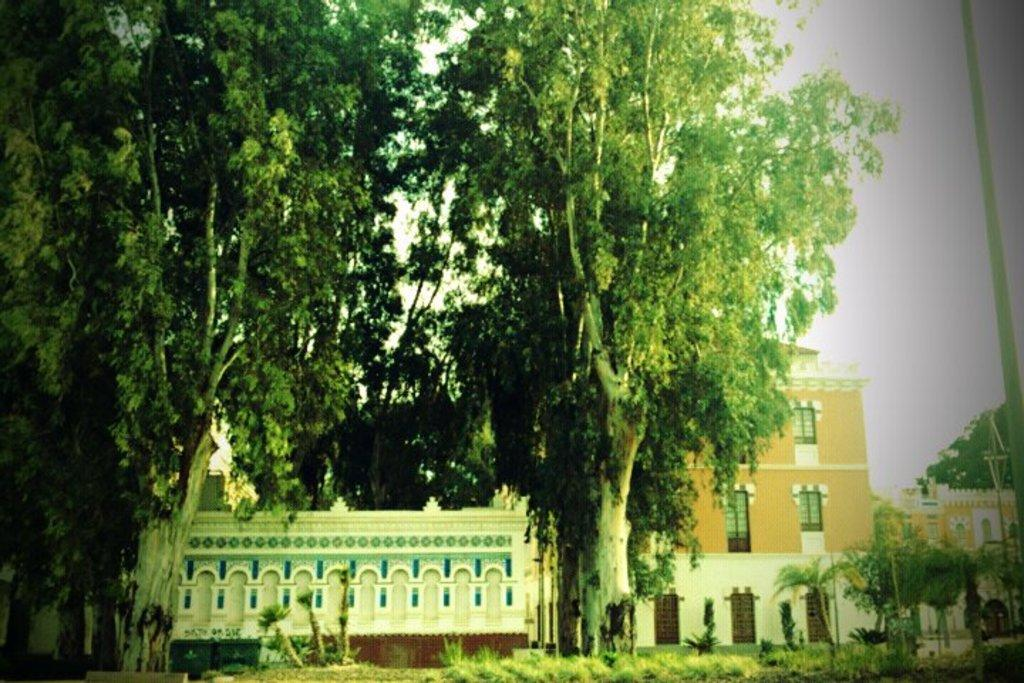What type of structures are visible in the image? There are buildings with windows and doors in the image. What can be seen in front of the buildings? Trees and grass are visible in front of the buildings. Where is the pole located in the image? The pole is on the right side of the image. What is visible in the background of the image? The sky and trees are visible in the background of the image. What type of food is being prepared on the side of the building in the image? There is no food preparation visible in the image; it only shows buildings, trees, grass, a pole, and the sky. 